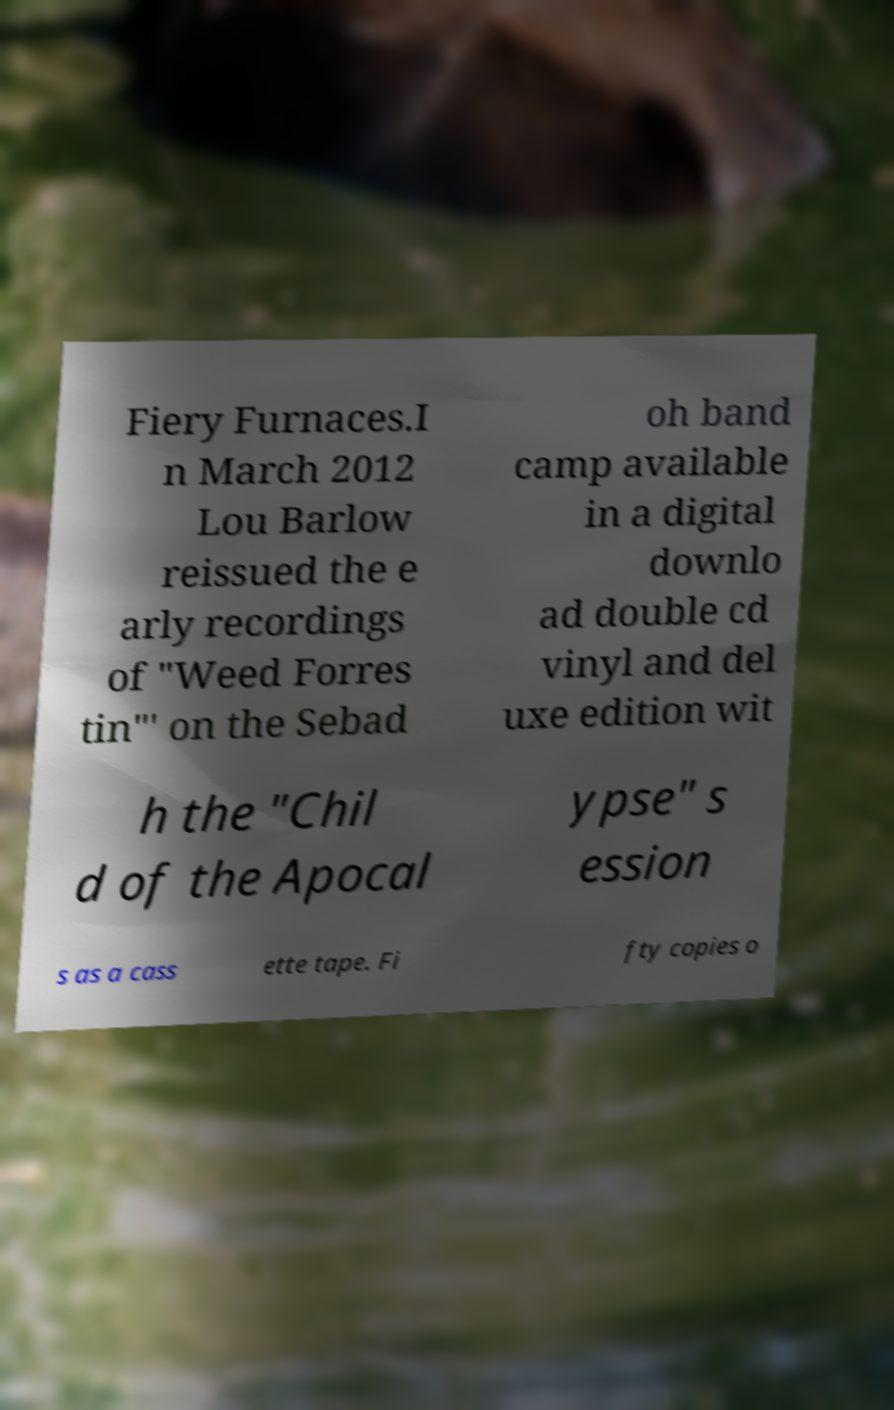Could you extract and type out the text from this image? Fiery Furnaces.I n March 2012 Lou Barlow reissued the e arly recordings of "Weed Forres tin"' on the Sebad oh band camp available in a digital downlo ad double cd vinyl and del uxe edition wit h the "Chil d of the Apocal ypse" s ession s as a cass ette tape. Fi fty copies o 